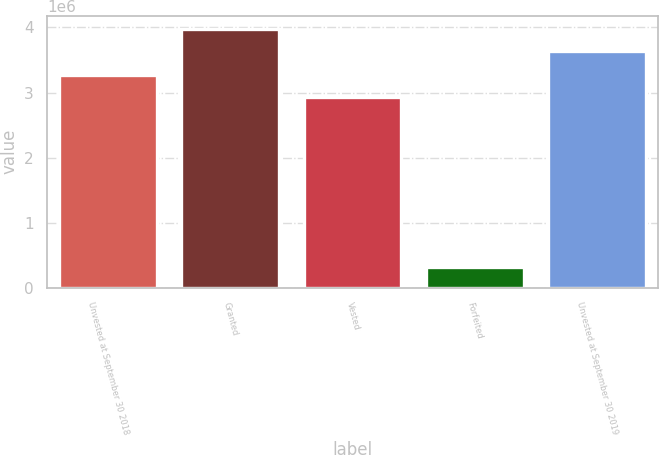Convert chart to OTSL. <chart><loc_0><loc_0><loc_500><loc_500><bar_chart><fcel>Unvested at September 30 2018<fcel>Granted<fcel>Vested<fcel>Forfeited<fcel>Unvested at September 30 2019<nl><fcel>3.26905e+06<fcel>3.98103e+06<fcel>2.93356e+06<fcel>318525<fcel>3.64554e+06<nl></chart> 